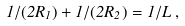Convert formula to latex. <formula><loc_0><loc_0><loc_500><loc_500>1 / ( 2 R _ { 1 } ) + 1 / ( 2 R _ { 2 } ) = 1 / L \, ,</formula> 